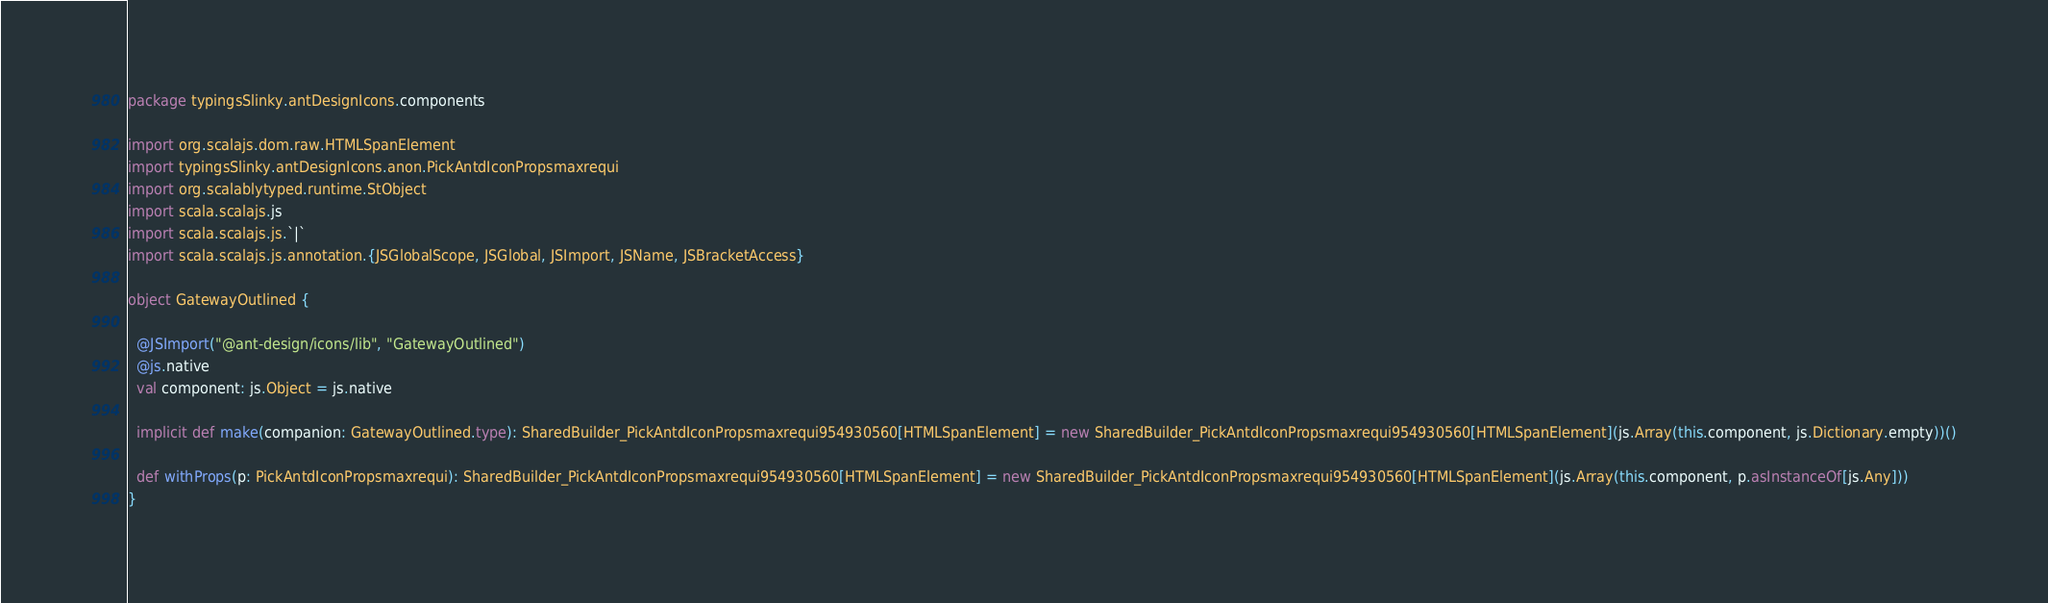Convert code to text. <code><loc_0><loc_0><loc_500><loc_500><_Scala_>package typingsSlinky.antDesignIcons.components

import org.scalajs.dom.raw.HTMLSpanElement
import typingsSlinky.antDesignIcons.anon.PickAntdIconPropsmaxrequi
import org.scalablytyped.runtime.StObject
import scala.scalajs.js
import scala.scalajs.js.`|`
import scala.scalajs.js.annotation.{JSGlobalScope, JSGlobal, JSImport, JSName, JSBracketAccess}

object GatewayOutlined {
  
  @JSImport("@ant-design/icons/lib", "GatewayOutlined")
  @js.native
  val component: js.Object = js.native
  
  implicit def make(companion: GatewayOutlined.type): SharedBuilder_PickAntdIconPropsmaxrequi954930560[HTMLSpanElement] = new SharedBuilder_PickAntdIconPropsmaxrequi954930560[HTMLSpanElement](js.Array(this.component, js.Dictionary.empty))()
  
  def withProps(p: PickAntdIconPropsmaxrequi): SharedBuilder_PickAntdIconPropsmaxrequi954930560[HTMLSpanElement] = new SharedBuilder_PickAntdIconPropsmaxrequi954930560[HTMLSpanElement](js.Array(this.component, p.asInstanceOf[js.Any]))
}
</code> 